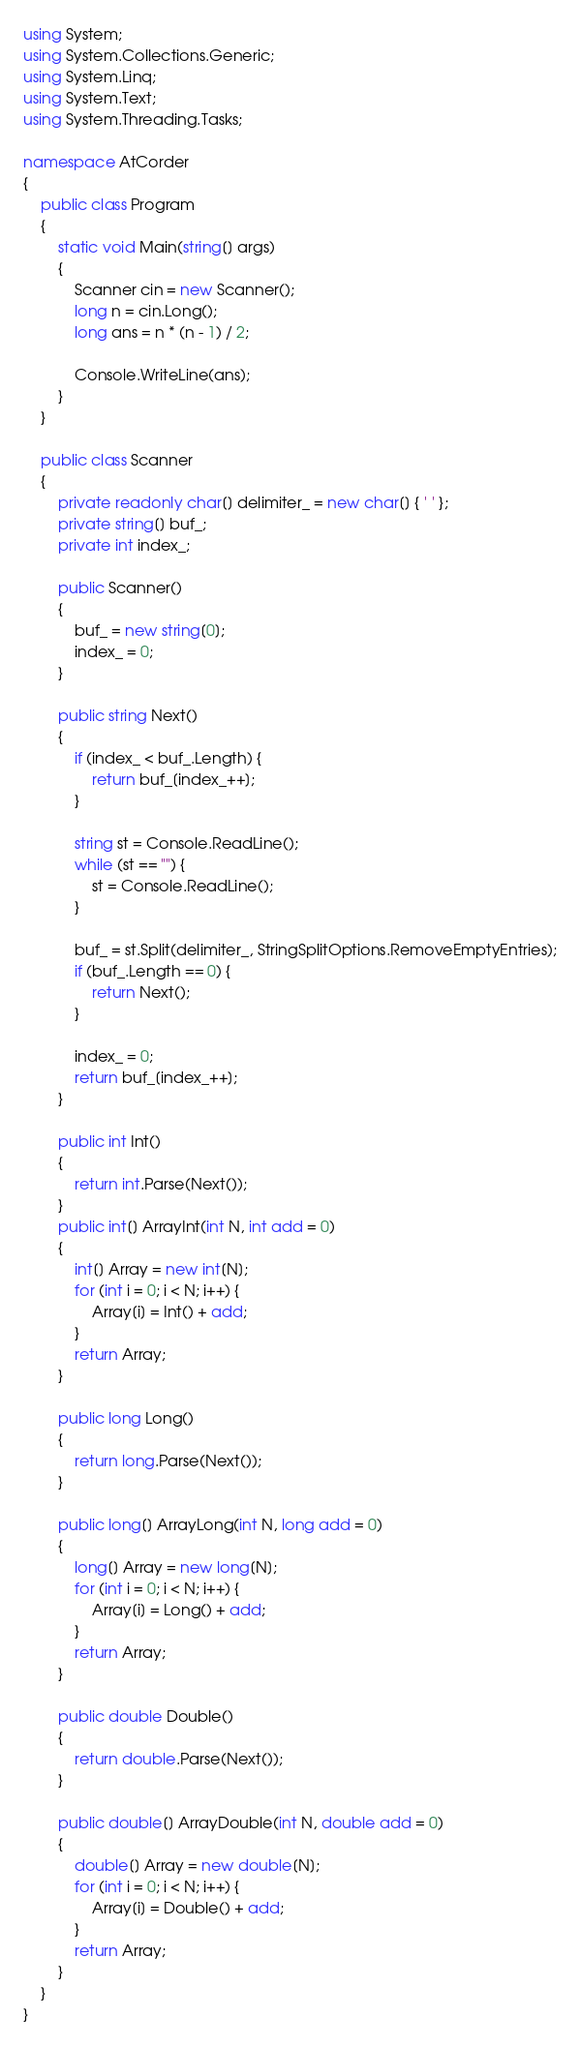<code> <loc_0><loc_0><loc_500><loc_500><_C#_>using System;
using System.Collections.Generic;
using System.Linq;
using System.Text;
using System.Threading.Tasks;

namespace AtCorder
{
	public class Program
	{
		static void Main(string[] args)
		{
			Scanner cin = new Scanner();
			long n = cin.Long();
			long ans = n * (n - 1) / 2;

			Console.WriteLine(ans);
		}
	}

	public class Scanner
	{
		private readonly char[] delimiter_ = new char[] { ' ' };
		private string[] buf_;
		private int index_;

		public Scanner()
		{
			buf_ = new string[0];
			index_ = 0;
		}

		public string Next()
		{
			if (index_ < buf_.Length) {
				return buf_[index_++];
			}

			string st = Console.ReadLine();
			while (st == "") {
				st = Console.ReadLine();
			}

			buf_ = st.Split(delimiter_, StringSplitOptions.RemoveEmptyEntries);
			if (buf_.Length == 0) {
				return Next();
			}

			index_ = 0;
			return buf_[index_++];
		}

		public int Int()
		{
			return int.Parse(Next());
		}
		public int[] ArrayInt(int N, int add = 0)
		{
			int[] Array = new int[N];
			for (int i = 0; i < N; i++) {
				Array[i] = Int() + add;
			}
			return Array;
		}

		public long Long()
		{
			return long.Parse(Next());
		}

		public long[] ArrayLong(int N, long add = 0)
		{
			long[] Array = new long[N];
			for (int i = 0; i < N; i++) {
				Array[i] = Long() + add;
			}
			return Array;
		}

		public double Double()
		{
			return double.Parse(Next());
		}

		public double[] ArrayDouble(int N, double add = 0)
		{
			double[] Array = new double[N];
			for (int i = 0; i < N; i++) {
				Array[i] = Double() + add;
			}
			return Array;
		}
	}
}</code> 